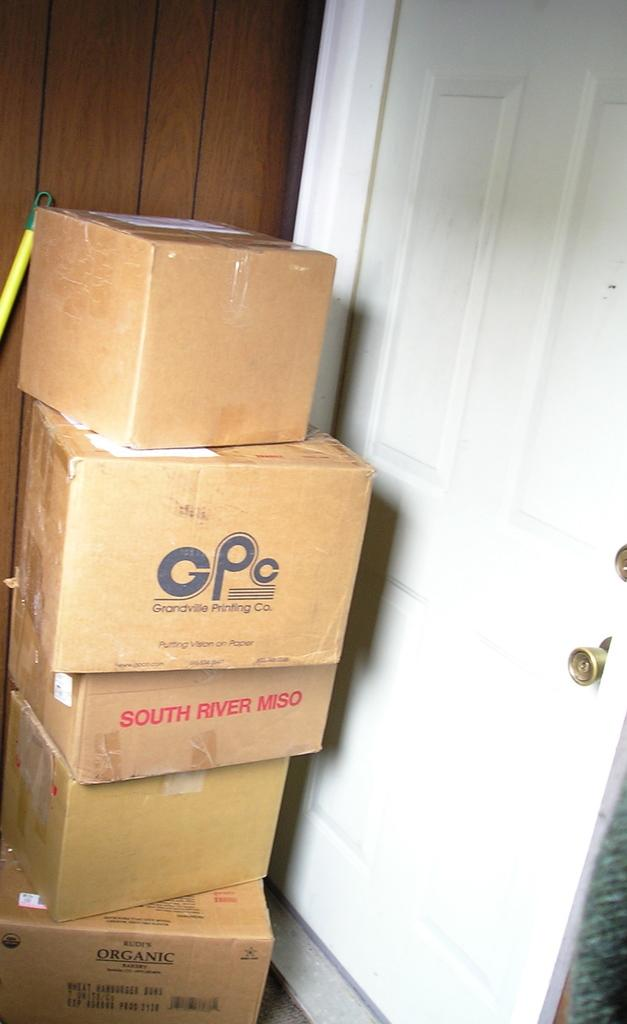<image>
Describe the image concisely. Boxes stacked on each other and one of them is labeled GPC 